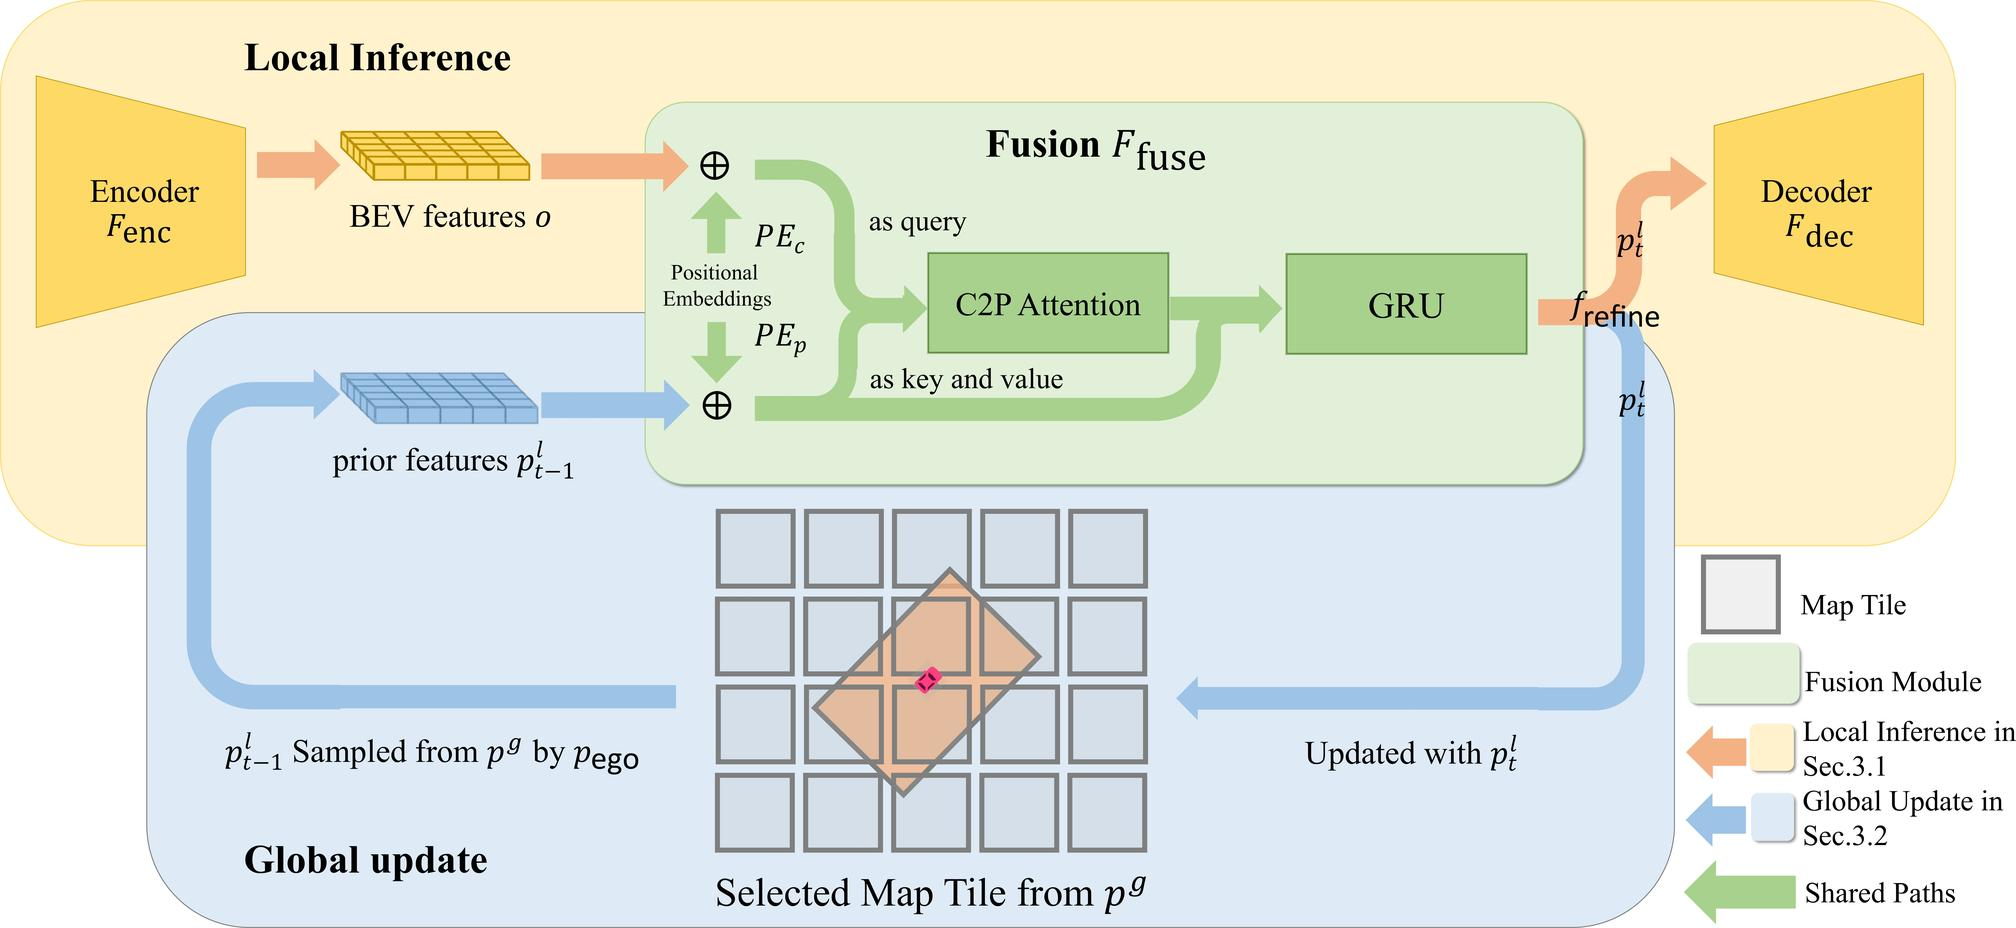What is the role of the GRU component in the given figure? A. To encode the BEV features for the first time. B. To act as a positional embedding for the C2P Attention module. C. To integrate temporal information from the fusion module. D. To decode the final output from the fused features. The GRU, which stands for Gated Recurrent Unit, is typically used to integrate information over time. In the context of the figure, the GRU is part of the fusion module, which suggests that it is used to integrate the output of the C2P Attention with prior features, thus incorporating temporal information to refine the prediction for \( p^t \). Therefore, the correct answer is C. 